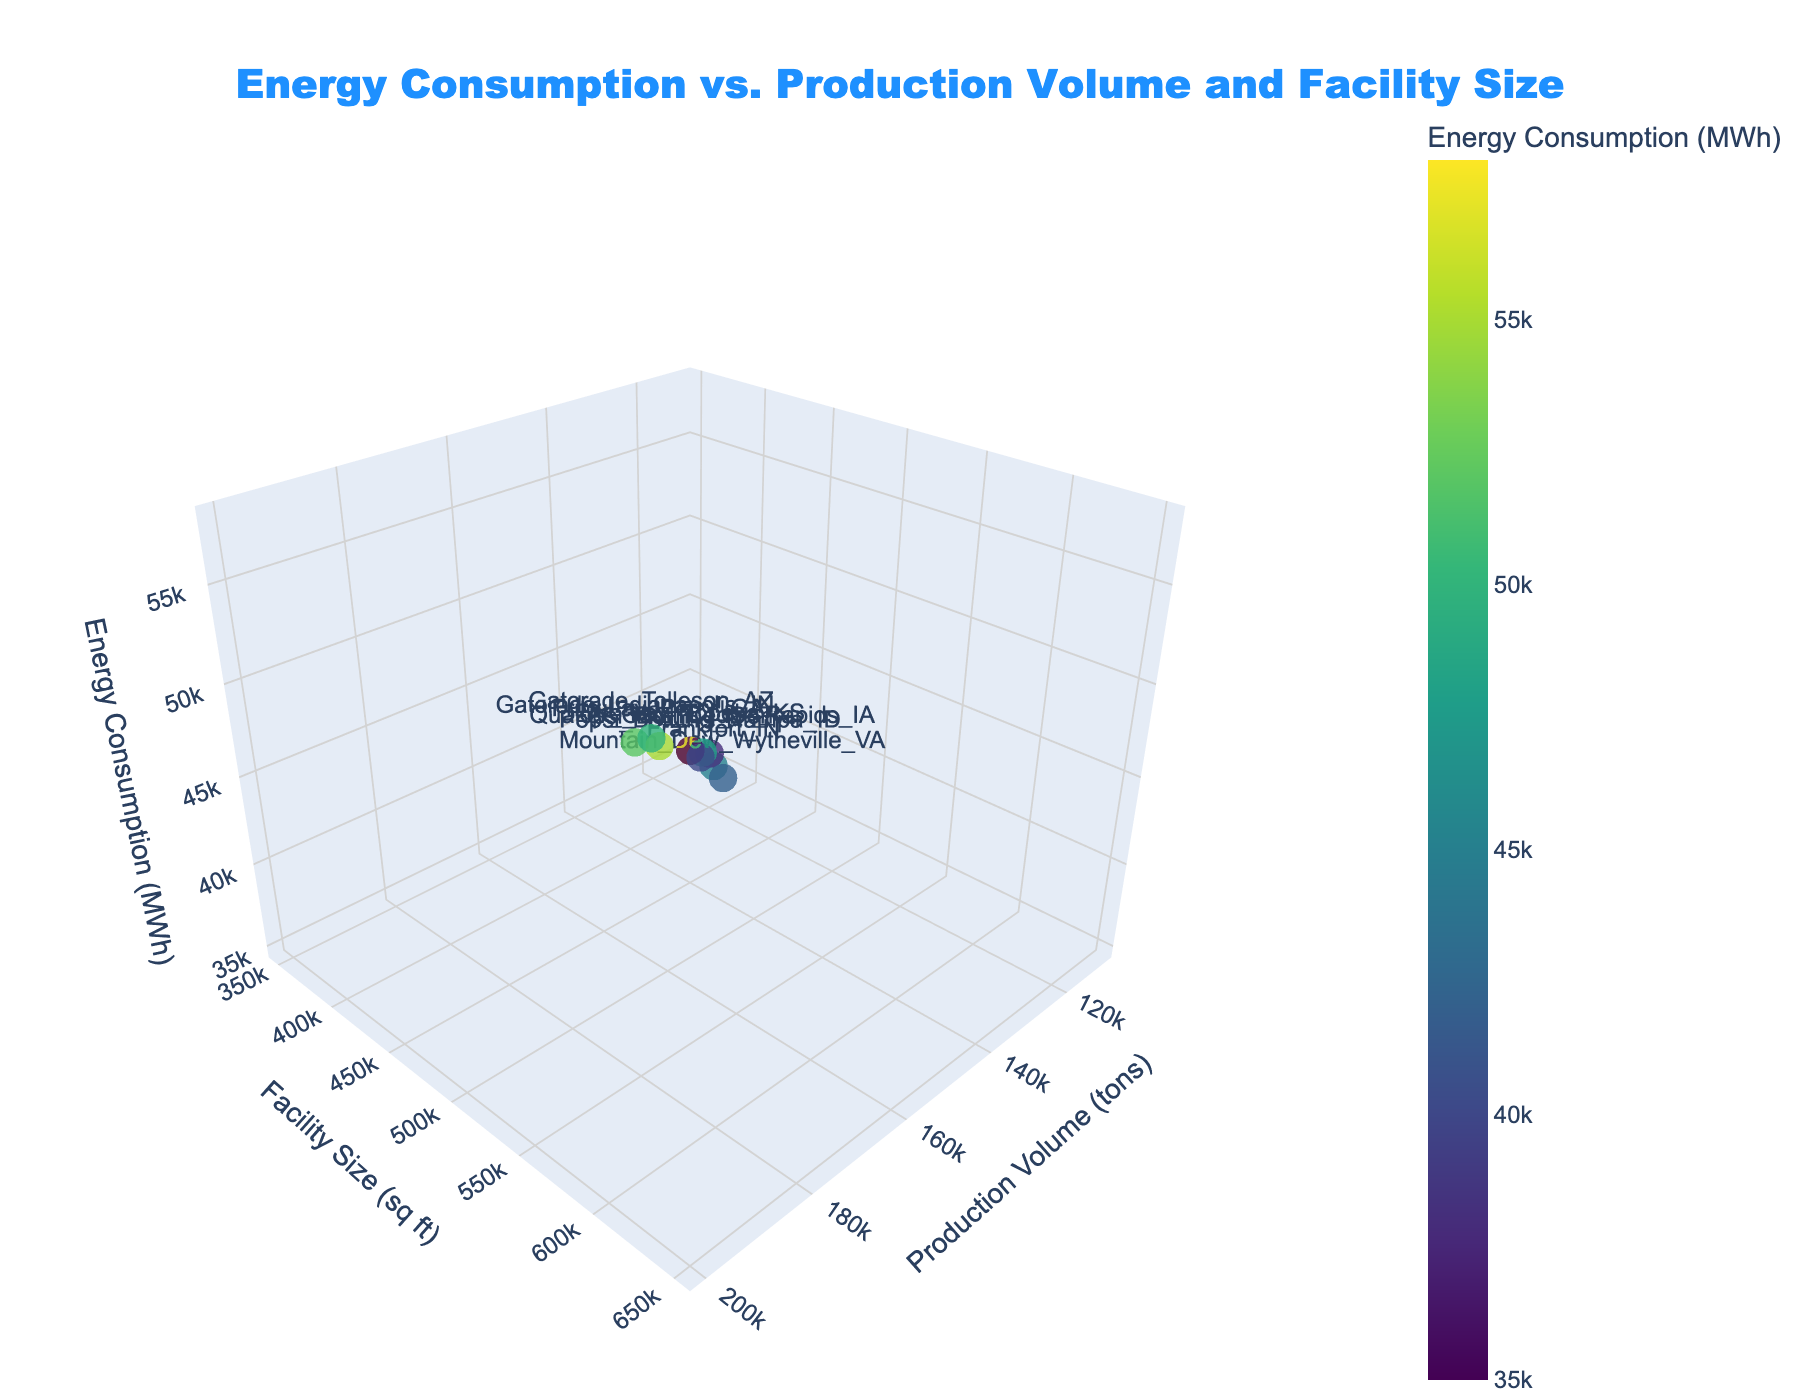What is the title of the figure? The title is displayed at the top of the plot. It summarizes what the plot illustrates.
Answer: Energy Consumption vs. Production Volume and Facility Size What is the facility with the highest energy consumption? The plot uses color to denote energy consumption levels. By hovering over or locating the highest color value, we identify the facility.
Answer: Frito-Lay Topeka, KS Which facility has the smallest production volume? The plot's x-axis represents production volume. The facility closest to the origin on the x-axis has the smallest value.
Answer: Pepsi Bottling Columbiana, OH Which axis shows the facility size, and what is its unit? By looking at the axis labels, the y-axis is identified as the facility size and its unit is in square feet.
Answer: y-axis, sq ft How do the energy consumptions of the Frankfort, IN, and Gatorade Indianapolis, IN facilities compare? Locate both facilities on the plot and compare their z-axis (energy consumption) values.
Answer: Frankfort, IN uses less energy than Gatorade Indianapolis, IN What's the difference in energy consumption between the highest and lowest consuming facilities? Identify the highest (Frito-Lay Topeka, KS) and lowest (Pepsi Bottling Columbiana, OH) energy consuming facilities, and then compute the difference. 58000 MWh - 35000 MWh = 23000 MWh
Answer: 23000 MWh How is the production volume related to the facility size in the plants? Observe the scatter distribution along the x and y axes to ascertain any visible correlation or trend between production volume and facility size values.
Answer: No clear correlation What's the average energy consumption among all the facilities? Sum the energy consumption values of all facilities and divide by the number of facilities: (45000 + 58000 + 52000 + 38000 + 48000 + 42000 + 35000 + 55000 + 50000 + 40000) / 10 = 46300 MWh
Answer: 46300 MWh Which facility has an intermediate (median) level of production volume? List all production volumes, find the middle value, and identify the corresponding facility. Volumes: 110000, 120000, 130000, 140000, 150000, 160000, 170000, 180000, 190000, 200000; Median is (150000+160000)/2 = 155000. Gatorade Indianapolis falls closest.
Answer: Gatorade Indianapolis, IN List the facilities that have energy consumption within ±5000 MWh of the Frankfort, IN one Determine the range: 45000 ± 5000 (40000 to 50000 MWh). Locate facilities within this range on the z-axis.
Answer: Mountain Dew Wytheville, VA; Pepsi Bottling Nampa, ID 